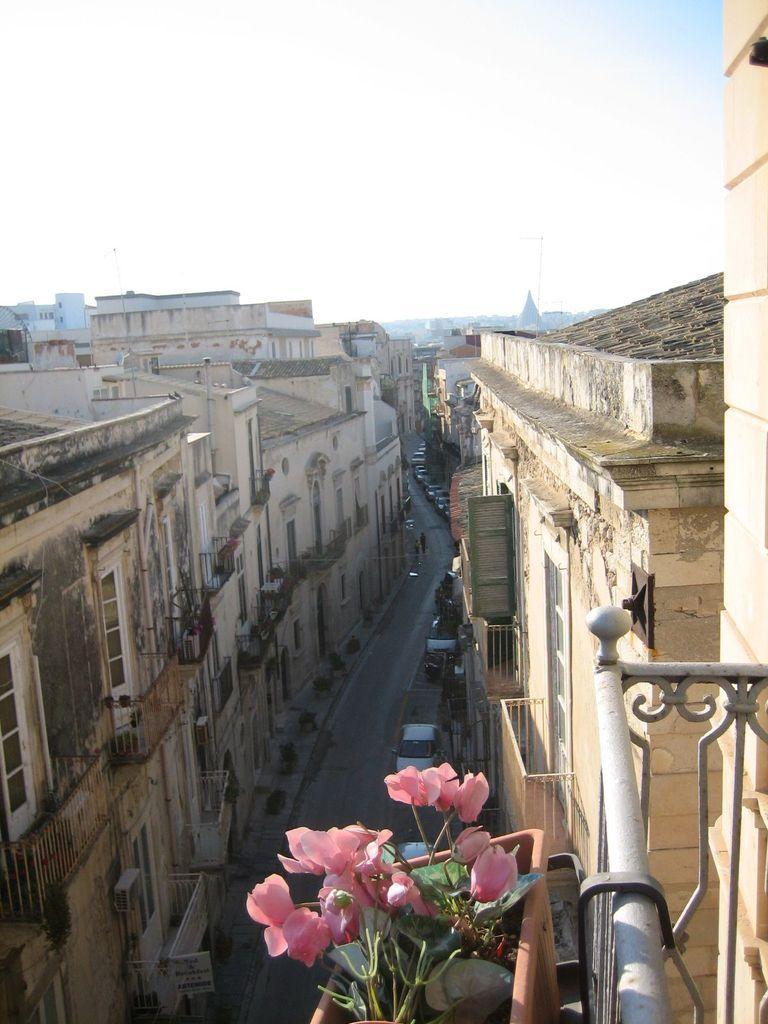Describe this image in one or two sentences. In the picture we can see an Aerial view of the road between the buildings and into the buildings we can see the windows and railing and to it we can see a plant with some flowers to it and in the background also we can see full of houses, buildings and sky. 